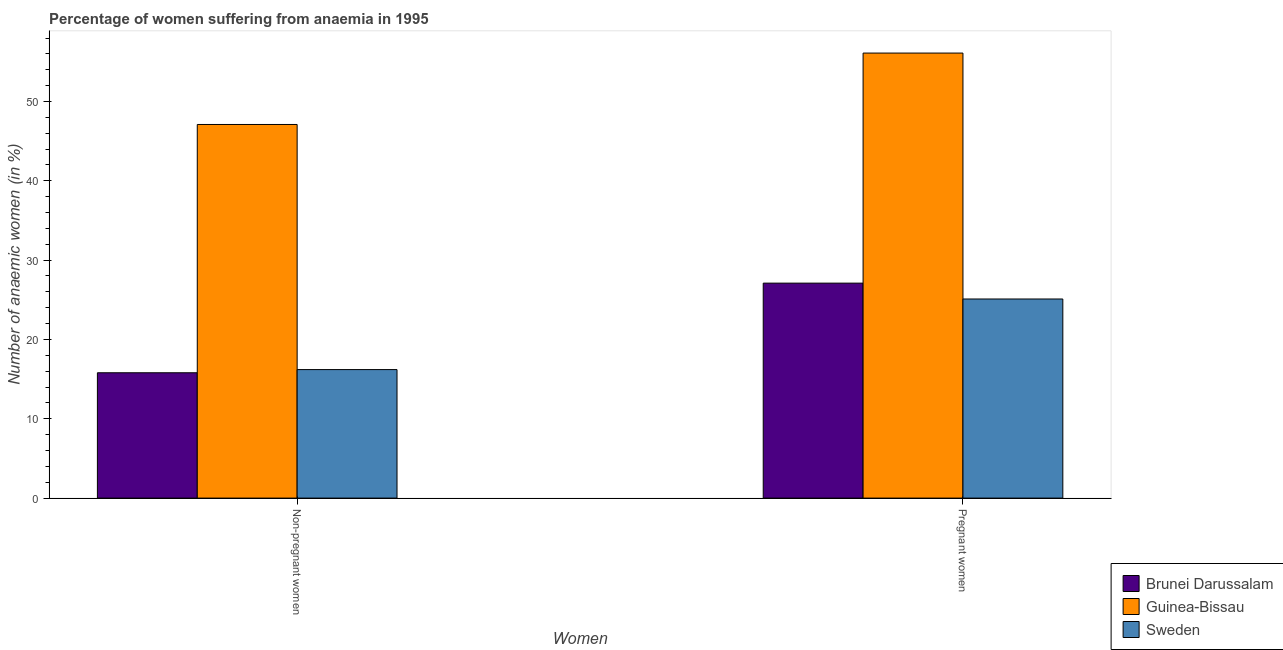How many different coloured bars are there?
Offer a terse response. 3. How many groups of bars are there?
Your answer should be very brief. 2. Are the number of bars per tick equal to the number of legend labels?
Your answer should be very brief. Yes. How many bars are there on the 2nd tick from the left?
Your response must be concise. 3. What is the label of the 1st group of bars from the left?
Offer a terse response. Non-pregnant women. What is the percentage of pregnant anaemic women in Guinea-Bissau?
Provide a short and direct response. 56.1. Across all countries, what is the maximum percentage of non-pregnant anaemic women?
Make the answer very short. 47.1. Across all countries, what is the minimum percentage of non-pregnant anaemic women?
Your answer should be very brief. 15.8. In which country was the percentage of non-pregnant anaemic women maximum?
Provide a succinct answer. Guinea-Bissau. In which country was the percentage of non-pregnant anaemic women minimum?
Keep it short and to the point. Brunei Darussalam. What is the total percentage of non-pregnant anaemic women in the graph?
Keep it short and to the point. 79.1. What is the difference between the percentage of pregnant anaemic women in Guinea-Bissau and that in Sweden?
Offer a terse response. 31. What is the difference between the percentage of pregnant anaemic women in Guinea-Bissau and the percentage of non-pregnant anaemic women in Sweden?
Your answer should be compact. 39.9. What is the average percentage of pregnant anaemic women per country?
Offer a terse response. 36.1. What is the ratio of the percentage of non-pregnant anaemic women in Brunei Darussalam to that in Sweden?
Provide a short and direct response. 0.98. What does the 1st bar from the right in Pregnant women represents?
Your answer should be compact. Sweden. How many bars are there?
Offer a terse response. 6. How many countries are there in the graph?
Keep it short and to the point. 3. What is the difference between two consecutive major ticks on the Y-axis?
Your response must be concise. 10. Are the values on the major ticks of Y-axis written in scientific E-notation?
Offer a very short reply. No. Does the graph contain any zero values?
Keep it short and to the point. No. Does the graph contain grids?
Your answer should be compact. No. How are the legend labels stacked?
Keep it short and to the point. Vertical. What is the title of the graph?
Provide a short and direct response. Percentage of women suffering from anaemia in 1995. What is the label or title of the X-axis?
Ensure brevity in your answer.  Women. What is the label or title of the Y-axis?
Provide a short and direct response. Number of anaemic women (in %). What is the Number of anaemic women (in %) of Guinea-Bissau in Non-pregnant women?
Provide a succinct answer. 47.1. What is the Number of anaemic women (in %) in Brunei Darussalam in Pregnant women?
Offer a very short reply. 27.1. What is the Number of anaemic women (in %) in Guinea-Bissau in Pregnant women?
Make the answer very short. 56.1. What is the Number of anaemic women (in %) of Sweden in Pregnant women?
Provide a succinct answer. 25.1. Across all Women, what is the maximum Number of anaemic women (in %) in Brunei Darussalam?
Offer a terse response. 27.1. Across all Women, what is the maximum Number of anaemic women (in %) in Guinea-Bissau?
Keep it short and to the point. 56.1. Across all Women, what is the maximum Number of anaemic women (in %) of Sweden?
Ensure brevity in your answer.  25.1. Across all Women, what is the minimum Number of anaemic women (in %) of Guinea-Bissau?
Provide a short and direct response. 47.1. Across all Women, what is the minimum Number of anaemic women (in %) of Sweden?
Offer a terse response. 16.2. What is the total Number of anaemic women (in %) of Brunei Darussalam in the graph?
Provide a succinct answer. 42.9. What is the total Number of anaemic women (in %) in Guinea-Bissau in the graph?
Provide a short and direct response. 103.2. What is the total Number of anaemic women (in %) in Sweden in the graph?
Offer a terse response. 41.3. What is the difference between the Number of anaemic women (in %) in Brunei Darussalam in Non-pregnant women and that in Pregnant women?
Your answer should be compact. -11.3. What is the difference between the Number of anaemic women (in %) of Brunei Darussalam in Non-pregnant women and the Number of anaemic women (in %) of Guinea-Bissau in Pregnant women?
Keep it short and to the point. -40.3. What is the difference between the Number of anaemic women (in %) of Guinea-Bissau in Non-pregnant women and the Number of anaemic women (in %) of Sweden in Pregnant women?
Offer a very short reply. 22. What is the average Number of anaemic women (in %) in Brunei Darussalam per Women?
Your answer should be very brief. 21.45. What is the average Number of anaemic women (in %) in Guinea-Bissau per Women?
Keep it short and to the point. 51.6. What is the average Number of anaemic women (in %) of Sweden per Women?
Keep it short and to the point. 20.65. What is the difference between the Number of anaemic women (in %) of Brunei Darussalam and Number of anaemic women (in %) of Guinea-Bissau in Non-pregnant women?
Your response must be concise. -31.3. What is the difference between the Number of anaemic women (in %) of Guinea-Bissau and Number of anaemic women (in %) of Sweden in Non-pregnant women?
Your answer should be very brief. 30.9. What is the difference between the Number of anaemic women (in %) in Brunei Darussalam and Number of anaemic women (in %) in Guinea-Bissau in Pregnant women?
Provide a short and direct response. -29. What is the ratio of the Number of anaemic women (in %) in Brunei Darussalam in Non-pregnant women to that in Pregnant women?
Offer a very short reply. 0.58. What is the ratio of the Number of anaemic women (in %) of Guinea-Bissau in Non-pregnant women to that in Pregnant women?
Provide a short and direct response. 0.84. What is the ratio of the Number of anaemic women (in %) of Sweden in Non-pregnant women to that in Pregnant women?
Ensure brevity in your answer.  0.65. What is the difference between the highest and the second highest Number of anaemic women (in %) of Brunei Darussalam?
Offer a terse response. 11.3. What is the difference between the highest and the lowest Number of anaemic women (in %) in Brunei Darussalam?
Make the answer very short. 11.3. What is the difference between the highest and the lowest Number of anaemic women (in %) in Guinea-Bissau?
Ensure brevity in your answer.  9. 